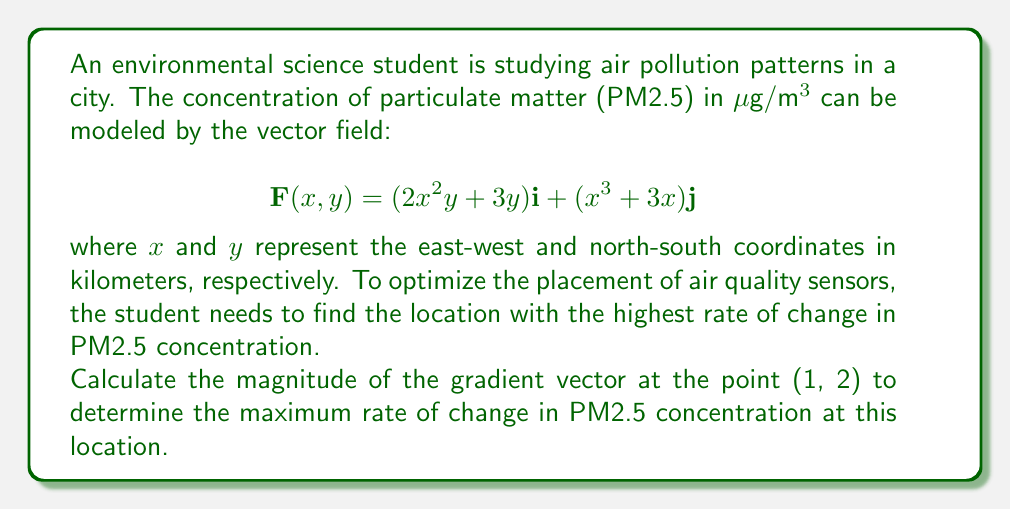Show me your answer to this math problem. To solve this problem, we need to follow these steps:

1) First, we need to find the gradient of the vector field. The gradient is given by:

   $$\nabla \mathbf{F} = \left(\frac{\partial F_x}{\partial x}, \frac{\partial F_y}{\partial y}\right)$$

2) Let's calculate each partial derivative:

   $$\frac{\partial F_x}{\partial x} = \frac{\partial}{\partial x}(2x^2y + 3y) = 4xy$$
   
   $$\frac{\partial F_y}{\partial y} = \frac{\partial}{\partial y}(x^3 + 3x) = 0$$

3) Therefore, the gradient vector is:

   $$\nabla \mathbf{F} = (4xy, 0)$$

4) Now, we need to evaluate this at the point (1, 2):

   $$\nabla \mathbf{F}(1,2) = (4(1)(2), 0) = (8, 0)$$

5) To find the magnitude of this gradient vector, we use the formula:

   $$|\nabla \mathbf{F}| = \sqrt{(4xy)^2 + 0^2}$$

6) Evaluating this at (1, 2):

   $$|\nabla \mathbf{F}(1,2)| = \sqrt{8^2 + 0^2} = \sqrt{64} = 8$$

Therefore, the maximum rate of change in PM2.5 concentration at the point (1, 2) is 8 μg/m³ per kilometer.
Answer: 8 μg/m³ per kilometer 